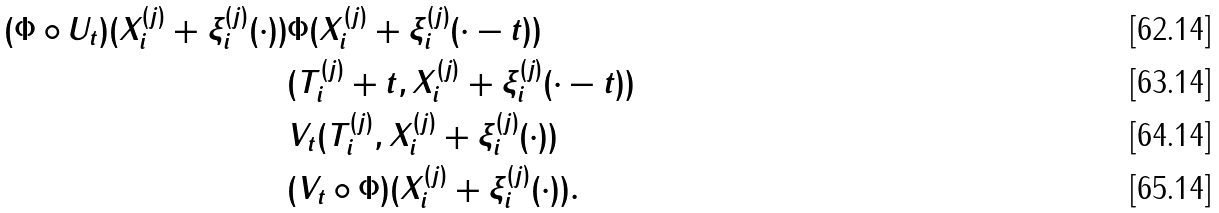<formula> <loc_0><loc_0><loc_500><loc_500>( \Phi \circ U _ { t } ) ( X _ { i } ^ { ( j ) } + \xi _ { i } ^ { ( j ) } ( \cdot ) ) & \Phi ( X _ { i } ^ { ( j ) } + \xi _ { i } ^ { ( j ) } ( \cdot - t ) ) \\ & ( T _ { i } ^ { ( j ) } + t , X _ { i } ^ { ( j ) } + \xi _ { i } ^ { ( j ) } ( \cdot - t ) ) \\ & V _ { t } ( T _ { i } ^ { ( j ) } , X _ { i } ^ { ( j ) } + \xi _ { i } ^ { ( j ) } ( \cdot ) ) \\ & ( V _ { t } \circ \Phi ) ( X _ { i } ^ { ( j ) } + \xi _ { i } ^ { ( j ) } ( \cdot ) ) .</formula> 